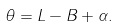<formula> <loc_0><loc_0><loc_500><loc_500>\theta = L - B + \alpha .</formula> 